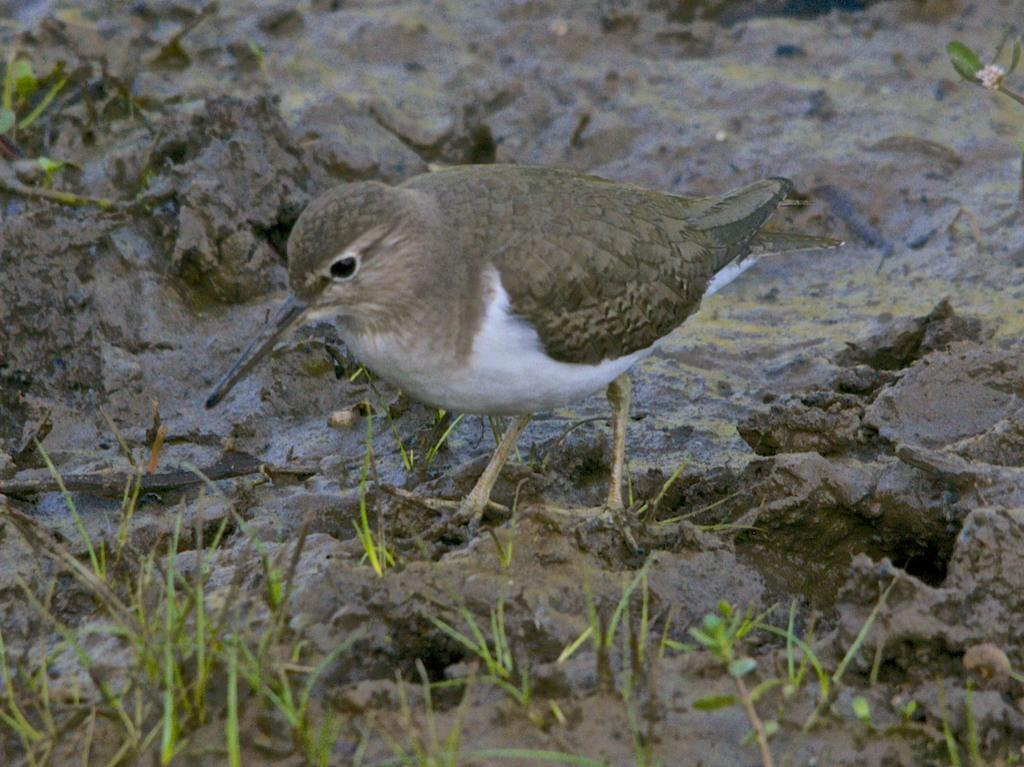What type of terrain is visible at the bottom of the picture? There is grass and mud at the bottom of the picture. What is the main subject in the middle of the picture? There is a bird in the middle of the picture. What colors can be seen on the bird? The bird has grey and white color. What is a distinctive feature of the bird? The bird has a long beak. What type of motion can be seen in space in the image? There is no motion in space visible in the image, as it features a bird in a grassy and muddy area. 